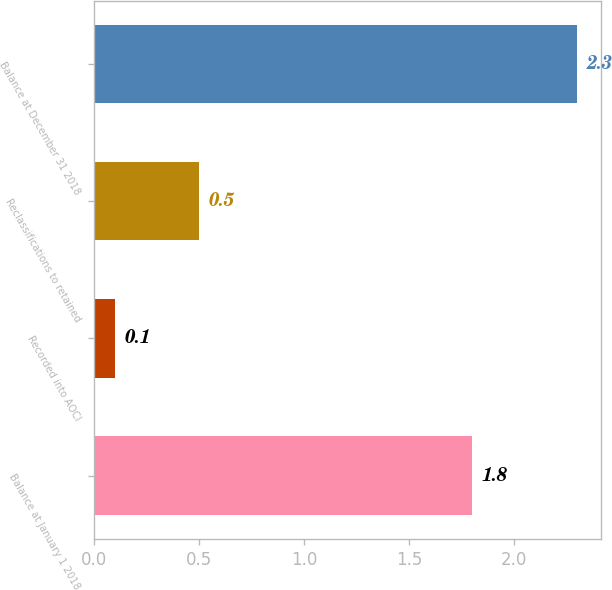Convert chart. <chart><loc_0><loc_0><loc_500><loc_500><bar_chart><fcel>Balance at January 1 2018<fcel>Recorded into AOCI<fcel>Reclassifications to retained<fcel>Balance at December 31 2018<nl><fcel>1.8<fcel>0.1<fcel>0.5<fcel>2.3<nl></chart> 